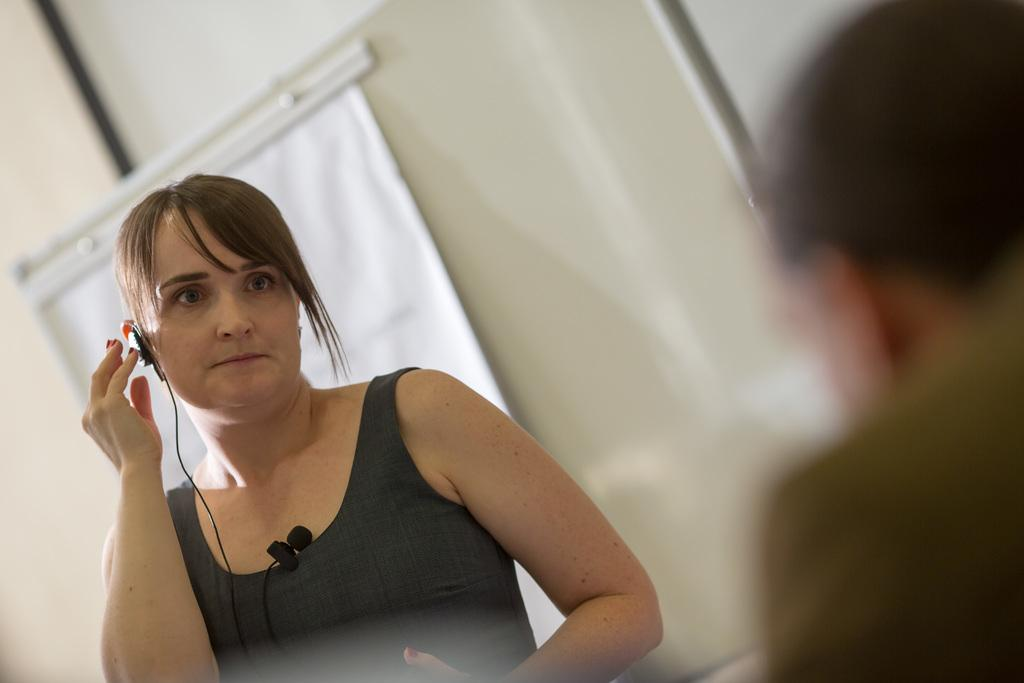Who is the main subject in the image? There is a woman in the image. What is the woman holding or wearing in the image? The woman has a mic attached to her. What can be seen in the background of the image? There is a poster on the wall in the background of the image. What type of test is the woman taking in the image? There is no test present in the image; the woman has a mic attached to her. What genre of fiction is depicted in the poster on the wall? There is no information about the genre of fiction in the poster on the wall, as the focus is on the woman with the mic. 